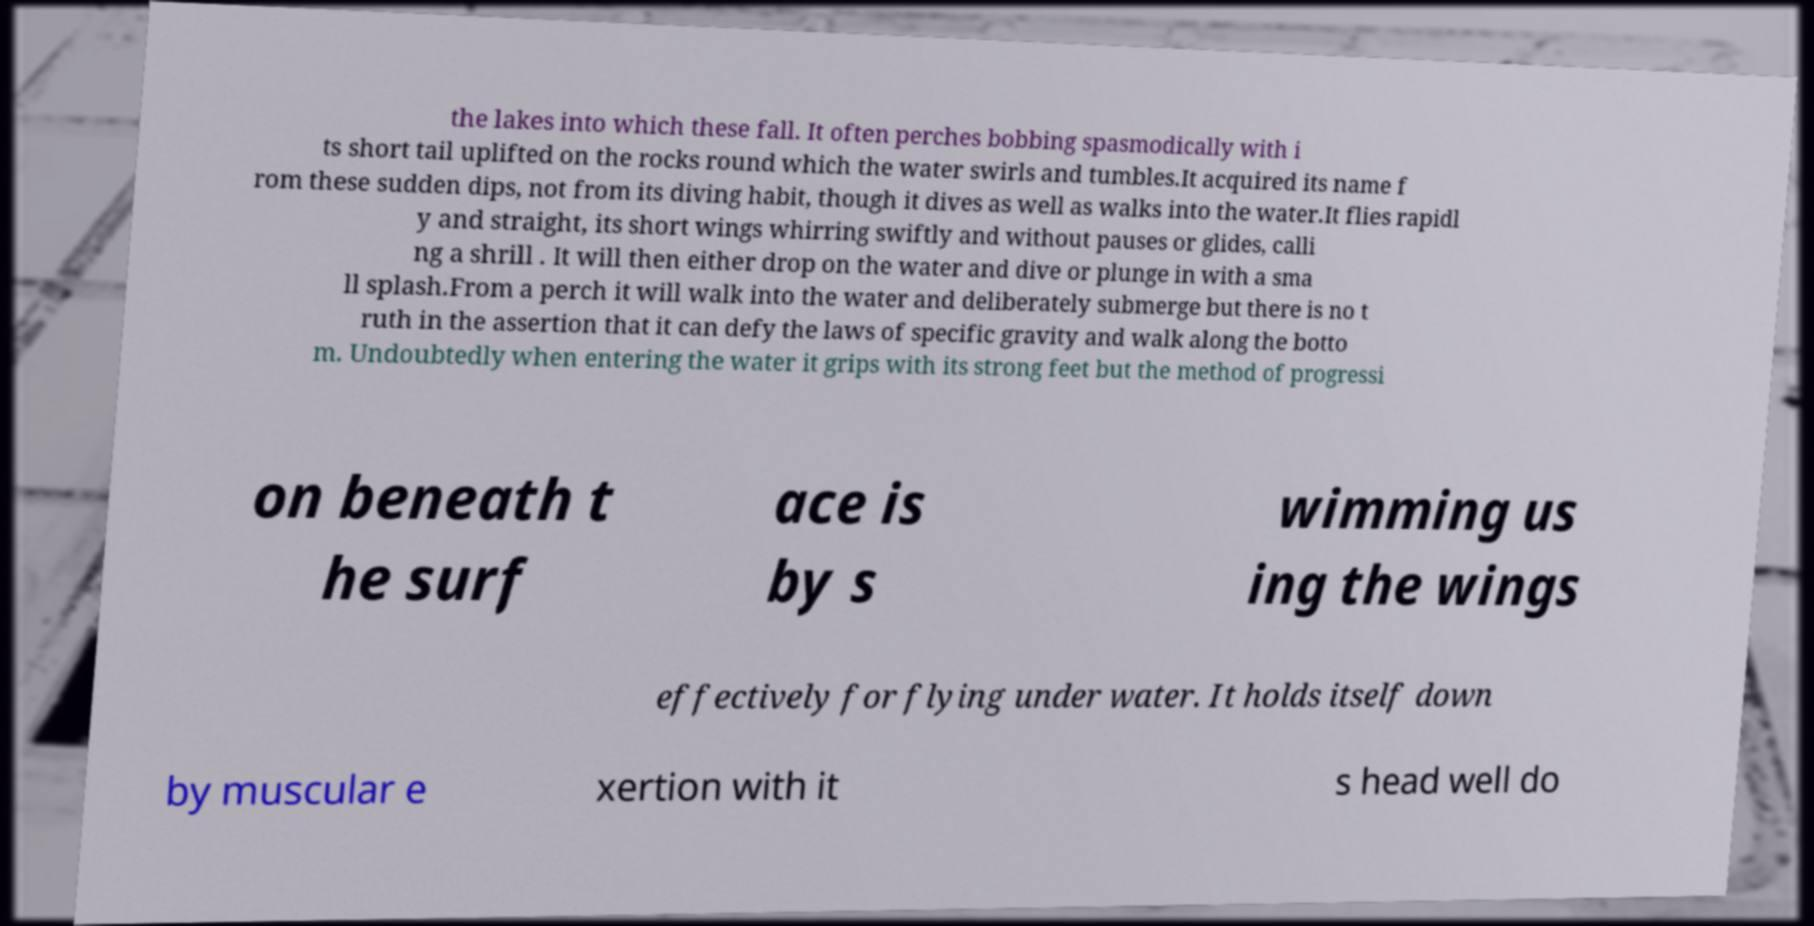Can you read and provide the text displayed in the image?This photo seems to have some interesting text. Can you extract and type it out for me? the lakes into which these fall. It often perches bobbing spasmodically with i ts short tail uplifted on the rocks round which the water swirls and tumbles.It acquired its name f rom these sudden dips, not from its diving habit, though it dives as well as walks into the water.It flies rapidl y and straight, its short wings whirring swiftly and without pauses or glides, calli ng a shrill . It will then either drop on the water and dive or plunge in with a sma ll splash.From a perch it will walk into the water and deliberately submerge but there is no t ruth in the assertion that it can defy the laws of specific gravity and walk along the botto m. Undoubtedly when entering the water it grips with its strong feet but the method of progressi on beneath t he surf ace is by s wimming us ing the wings effectively for flying under water. It holds itself down by muscular e xertion with it s head well do 